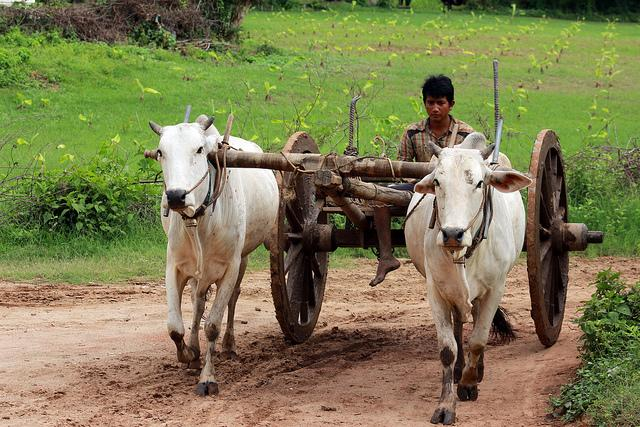What kind of animal is the cart pulled by? oxen 